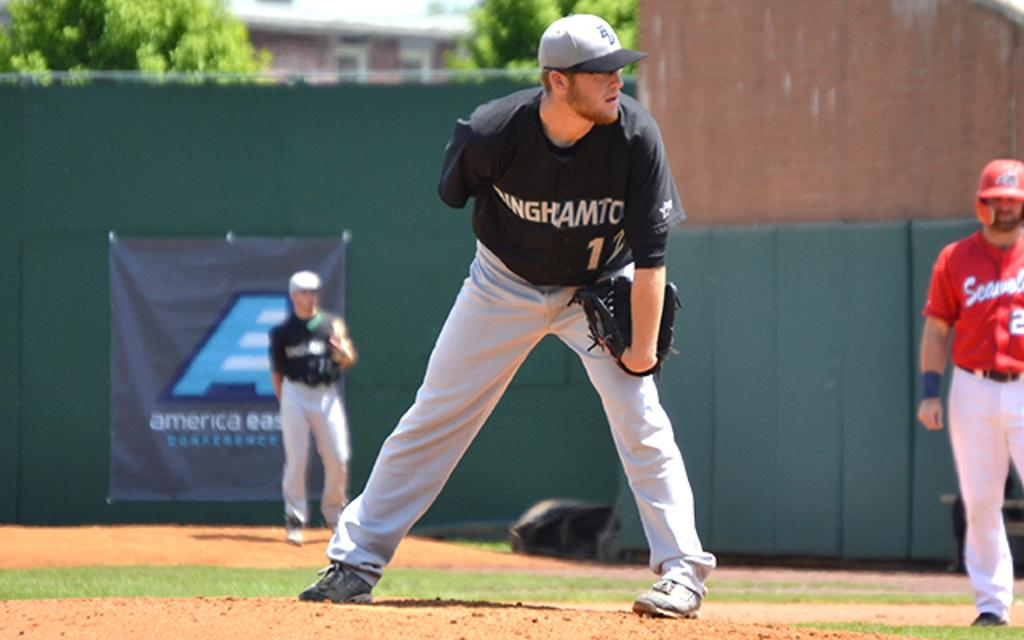<image>
Relay a brief, clear account of the picture shown. The Binghamton pitcher wearing number 12 prepares to throw a pitch. 